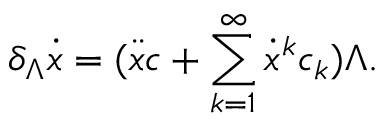Convert formula to latex. <formula><loc_0><loc_0><loc_500><loc_500>\delta _ { \Lambda } \dot { x } = ( \ddot { x } c + \sum _ { k = 1 } ^ { \infty } \dot { x } ^ { k } c _ { k } ) \Lambda .</formula> 